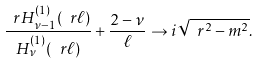<formula> <loc_0><loc_0><loc_500><loc_500>\frac { \ r H _ { \nu - 1 } ^ { ( 1 ) } ( \ r \ell ) } { H _ { \nu } ^ { ( 1 ) } ( \ r \ell ) } + \frac { 2 - \nu } { \ell } \to i \sqrt { \ r ^ { 2 } - m ^ { 2 } } .</formula> 